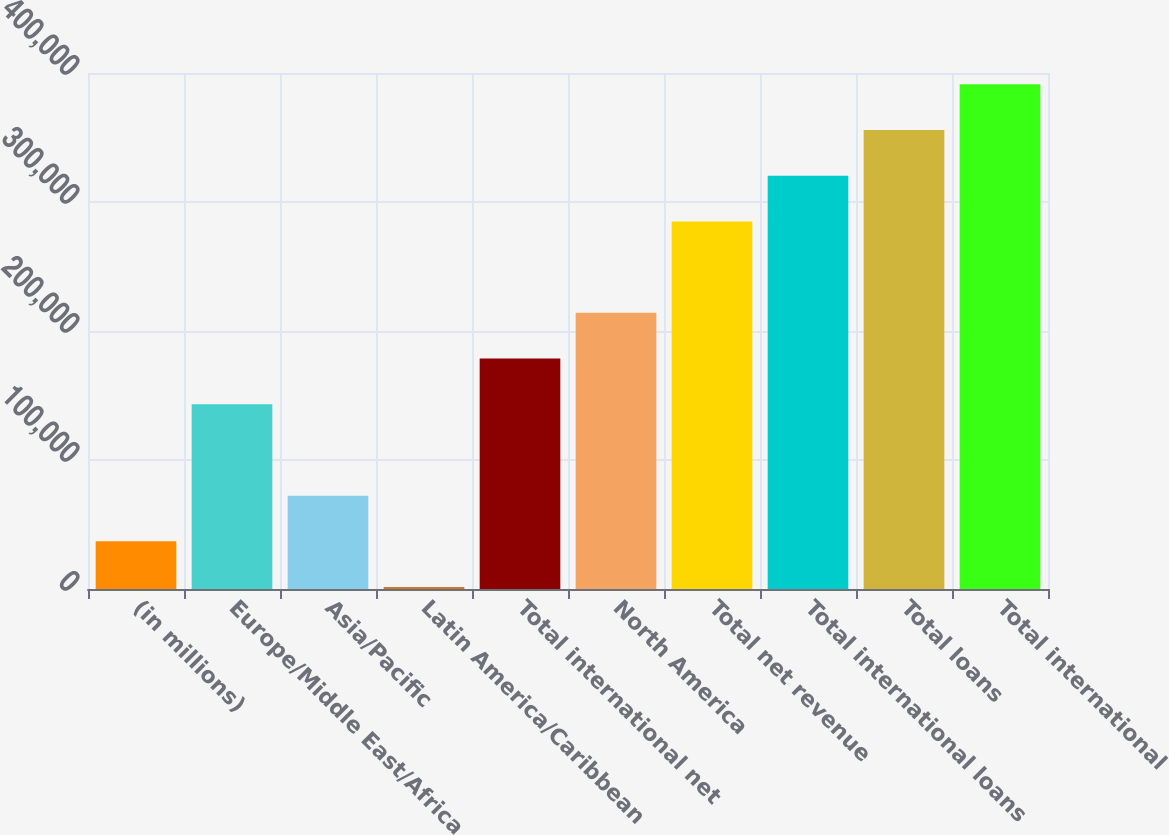Convert chart to OTSL. <chart><loc_0><loc_0><loc_500><loc_500><bar_chart><fcel>(in millions)<fcel>Europe/Middle East/Africa<fcel>Asia/Pacific<fcel>Latin America/Caribbean<fcel>Total international net<fcel>North America<fcel>Total net revenue<fcel>Total international loans<fcel>Total loans<fcel>Total international<nl><fcel>36948.2<fcel>143221<fcel>72372.4<fcel>1524<fcel>178645<fcel>214069<fcel>284918<fcel>320342<fcel>355766<fcel>391190<nl></chart> 